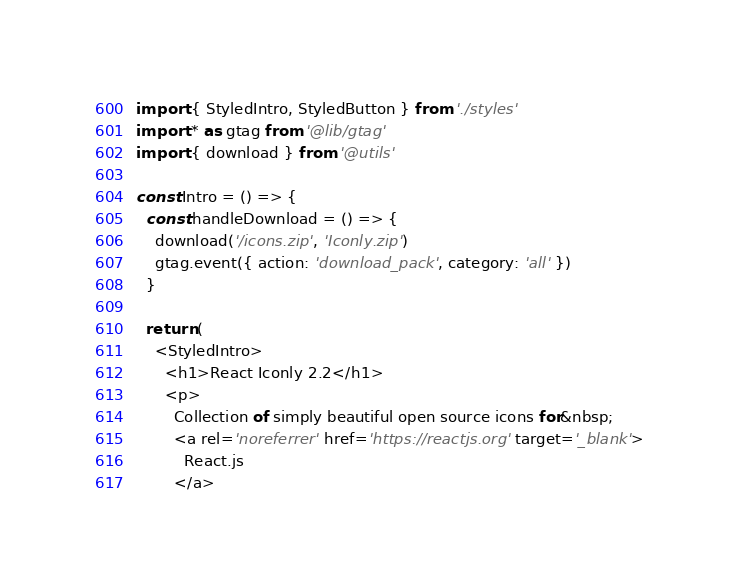<code> <loc_0><loc_0><loc_500><loc_500><_JavaScript_>import { StyledIntro, StyledButton } from './styles'
import * as gtag from '@lib/gtag'
import { download } from '@utils'

const Intro = () => {
  const handleDownload = () => {
    download('/icons.zip', 'Iconly.zip')
    gtag.event({ action: 'download_pack', category: 'all' })
  }

  return (
    <StyledIntro>
      <h1>React Iconly 2.2</h1>
      <p>
        Collection of simply beautiful open source icons for&nbsp;
        <a rel='noreferrer' href='https://reactjs.org' target='_blank'>
          React.js
        </a></code> 